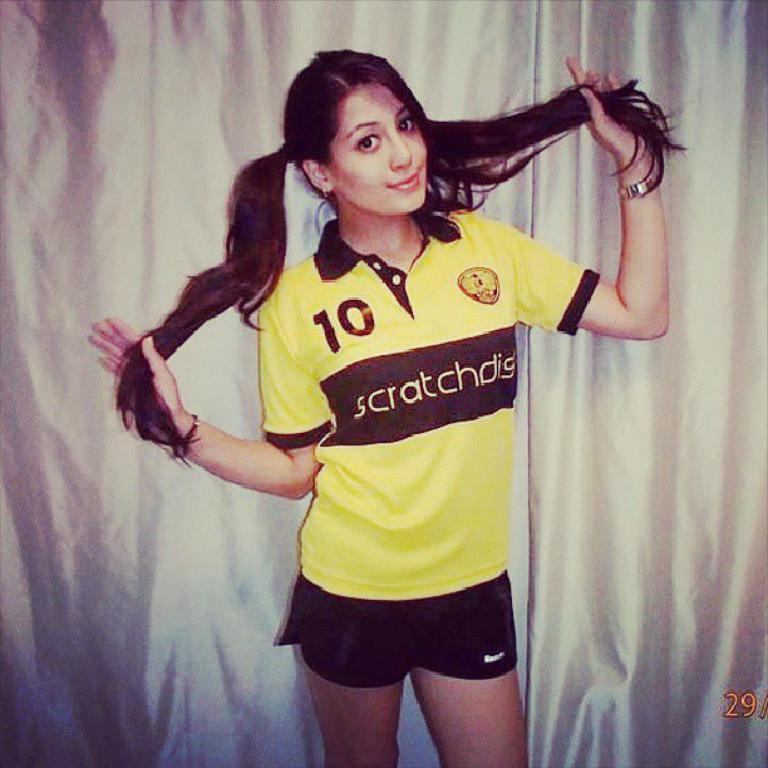Where was the image taken? The image was taken indoors. What can be seen in the background of the image? There is a curtain in the background of the image. Who is the main subject in the image? A: A girl is standing in the middle of the image. What is the girl's facial expression? The girl has a smiling face. What type of industry can be seen in the background of the image? There is no industry present in the background of the image; it features a curtain. What type of work is the girl doing in the image? The girl is not depicted as doing any work in the image; she is simply standing with a smiling face. 